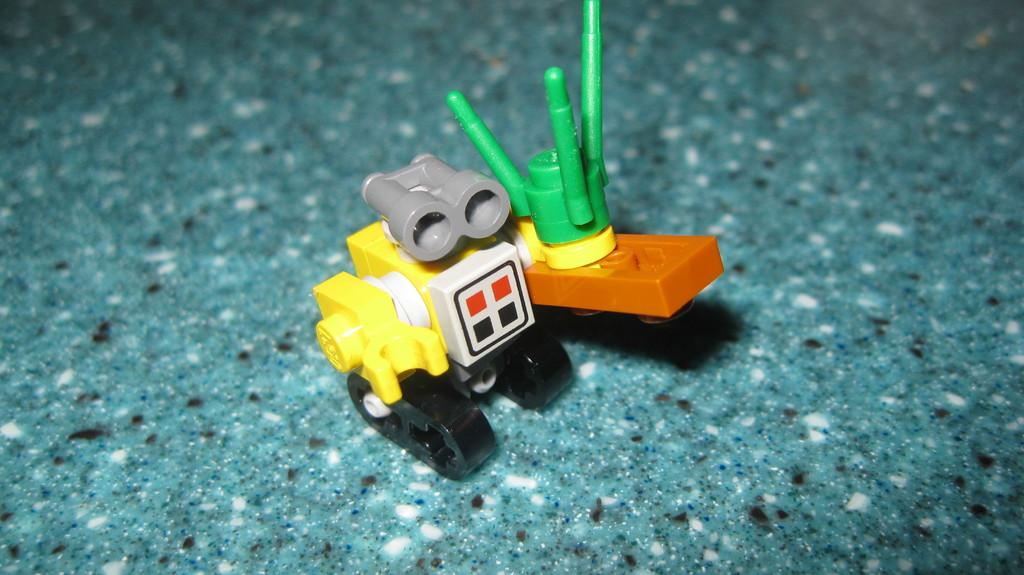What type of toy is visible in the image? There is a toy made of blocks in the image. Where is the toy located in the image? The toy is on the floor. What type of business is being conducted near the toy in the image? There is no indication of a business or any business-related activity in the image. 